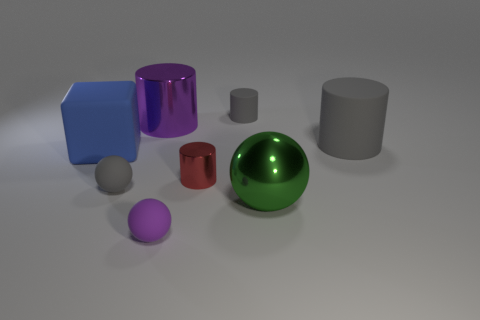Subtract 1 cylinders. How many cylinders are left? 3 Subtract all blue cylinders. Subtract all green spheres. How many cylinders are left? 4 Add 1 big yellow rubber blocks. How many objects exist? 9 Subtract all balls. How many objects are left? 5 Add 5 small gray rubber balls. How many small gray rubber balls are left? 6 Add 3 matte objects. How many matte objects exist? 8 Subtract 0 purple cubes. How many objects are left? 8 Subtract all gray objects. Subtract all purple shiny cylinders. How many objects are left? 4 